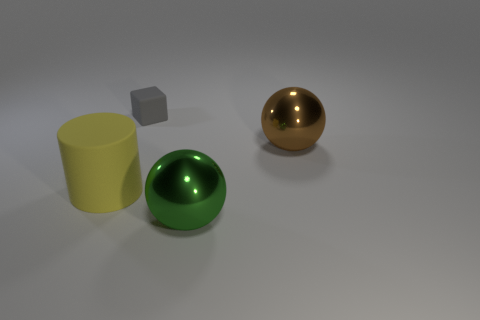What is the large green thing made of?
Your response must be concise. Metal. What number of other big yellow cylinders have the same material as the yellow cylinder?
Give a very brief answer. 0. What number of matte things are big green balls or big yellow objects?
Provide a short and direct response. 1. Does the object in front of the big cylinder have the same shape as the matte object that is in front of the large brown metallic sphere?
Make the answer very short. No. What color is the thing that is both to the left of the green metallic ball and right of the large yellow matte object?
Offer a very short reply. Gray. Is the size of the object on the left side of the gray rubber block the same as the matte object that is behind the cylinder?
Your response must be concise. No. How many tiny objects are green cylinders or matte things?
Keep it short and to the point. 1. Are the object that is in front of the large yellow cylinder and the brown sphere made of the same material?
Keep it short and to the point. Yes. What is the color of the large ball that is in front of the matte cylinder?
Your response must be concise. Green. Is there a rubber cylinder of the same size as the green thing?
Make the answer very short. Yes. 